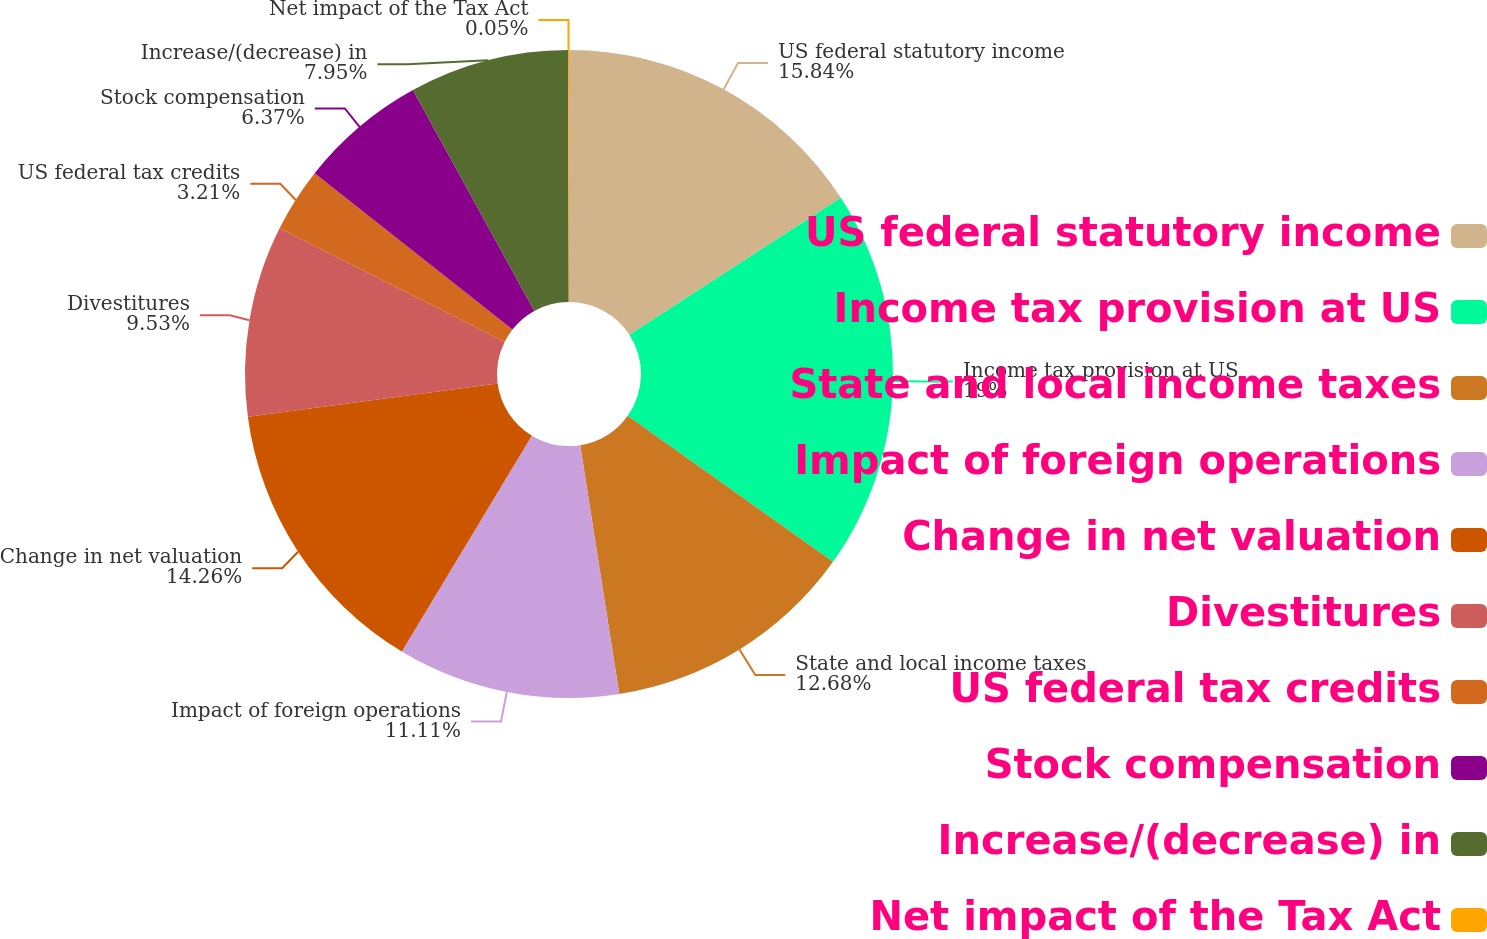Convert chart to OTSL. <chart><loc_0><loc_0><loc_500><loc_500><pie_chart><fcel>US federal statutory income<fcel>Income tax provision at US<fcel>State and local income taxes<fcel>Impact of foreign operations<fcel>Change in net valuation<fcel>Divestitures<fcel>US federal tax credits<fcel>Stock compensation<fcel>Increase/(decrease) in<fcel>Net impact of the Tax Act<nl><fcel>15.84%<fcel>19.0%<fcel>12.68%<fcel>11.11%<fcel>14.26%<fcel>9.53%<fcel>3.21%<fcel>6.37%<fcel>7.95%<fcel>0.05%<nl></chart> 